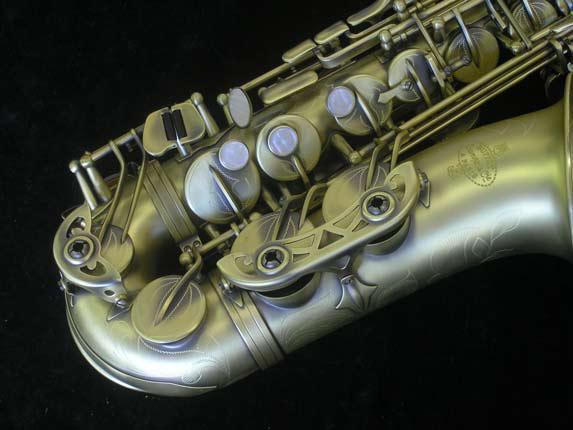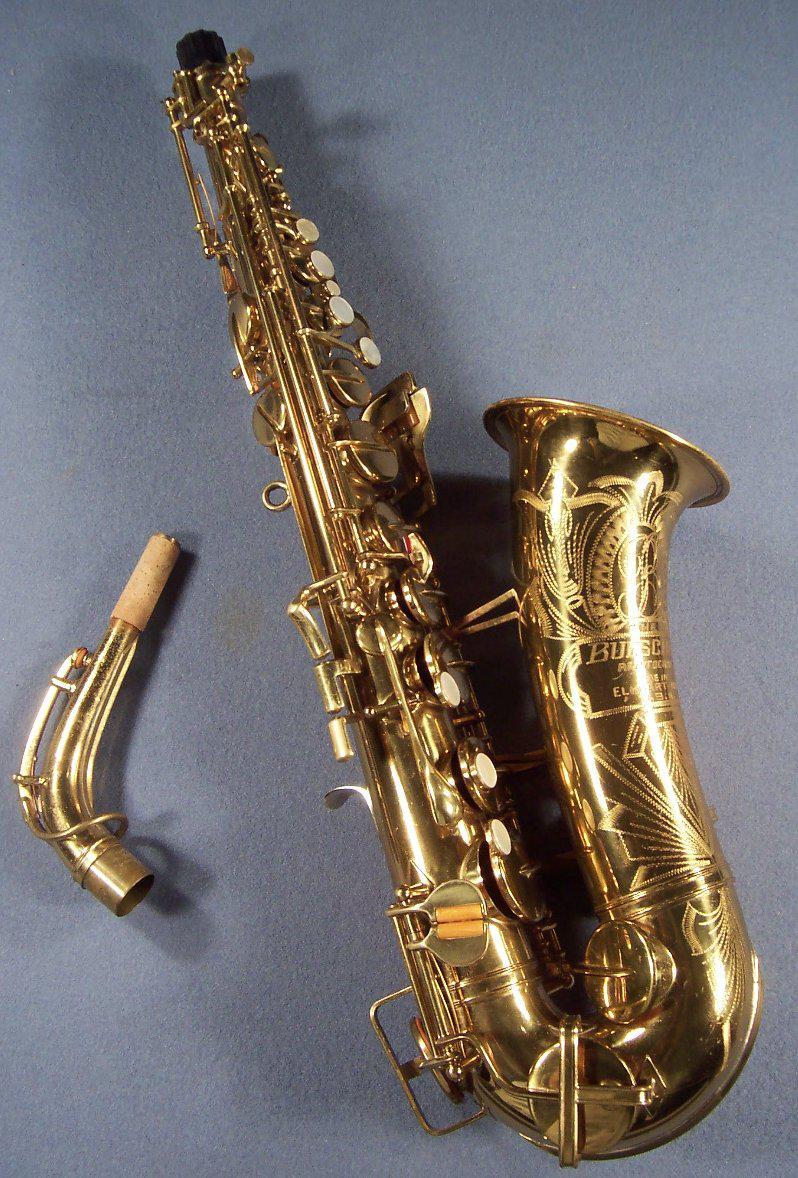The first image is the image on the left, the second image is the image on the right. For the images displayed, is the sentence "There are at exactly two saxophones in one of the images." factually correct? Answer yes or no. No. The first image is the image on the left, the second image is the image on the right. For the images displayed, is the sentence "No image shows more than one saxophone." factually correct? Answer yes or no. Yes. 